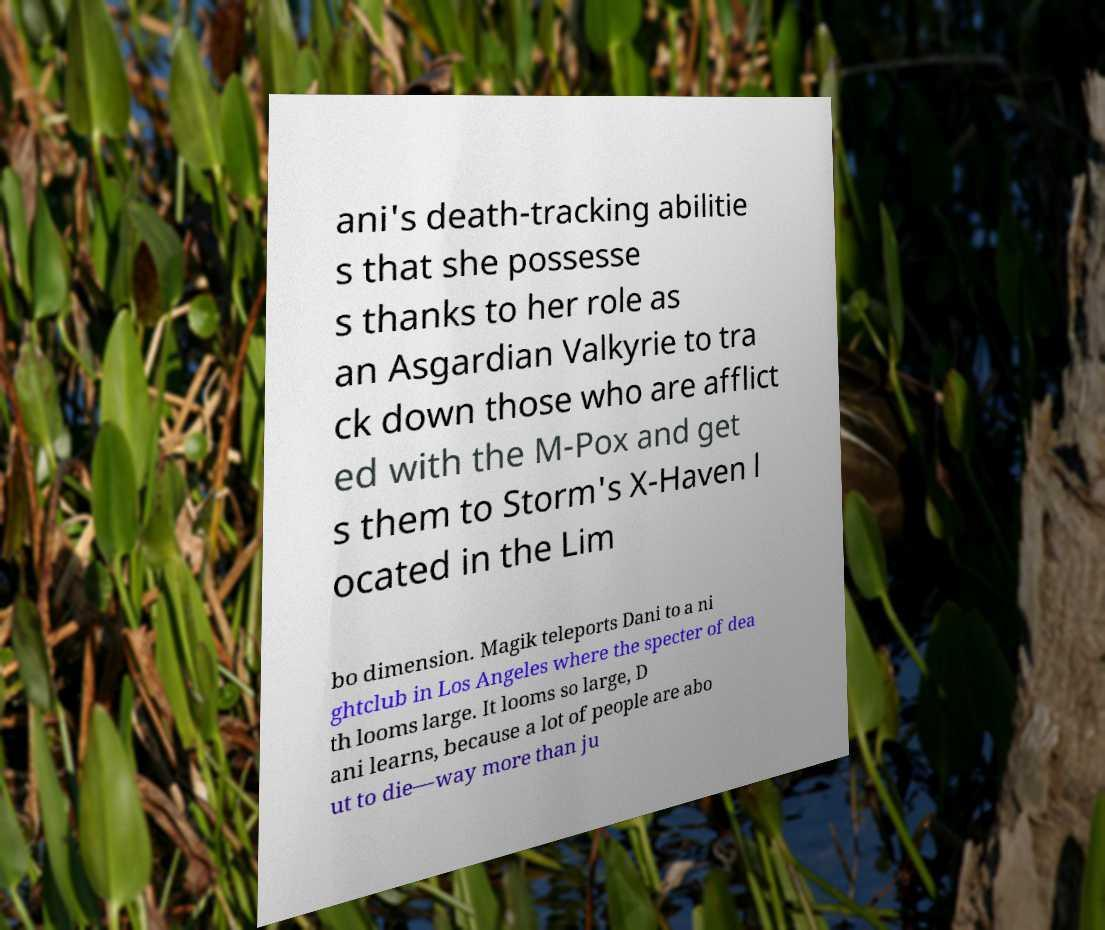Please identify and transcribe the text found in this image. ani's death-tracking abilitie s that she possesse s thanks to her role as an Asgardian Valkyrie to tra ck down those who are afflict ed with the M-Pox and get s them to Storm's X-Haven l ocated in the Lim bo dimension. Magik teleports Dani to a ni ghtclub in Los Angeles where the specter of dea th looms large. It looms so large, D ani learns, because a lot of people are abo ut to die—way more than ju 